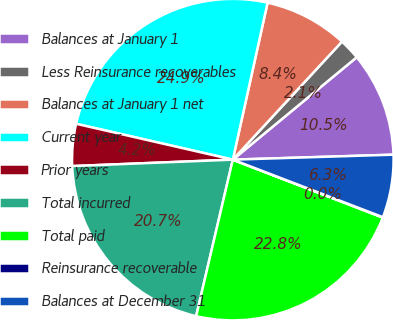<chart> <loc_0><loc_0><loc_500><loc_500><pie_chart><fcel>Balances at January 1<fcel>Less Reinsurance recoverables<fcel>Balances at January 1 net<fcel>Current year<fcel>Prior years<fcel>Total incurred<fcel>Total paid<fcel>Reinsurance recoverable<fcel>Balances at December 31<nl><fcel>10.5%<fcel>2.13%<fcel>8.41%<fcel>24.89%<fcel>4.22%<fcel>20.7%<fcel>22.8%<fcel>0.04%<fcel>6.32%<nl></chart> 